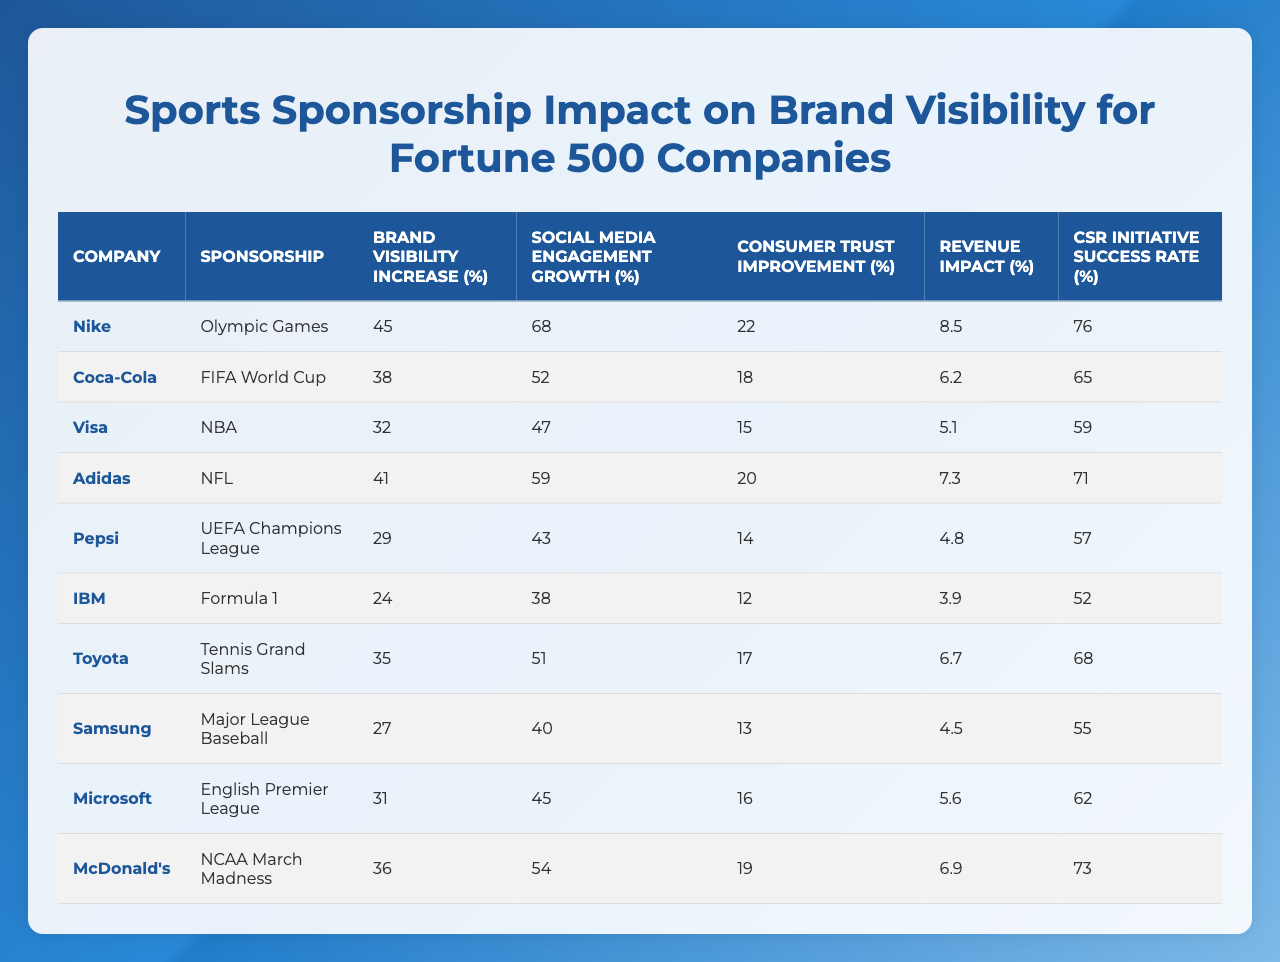What company has the highest brand visibility increase? By scanning the "Brand Visibility Increase" column, I identify Nike with a value of 45, which is the highest compared to other companies listed.
Answer: Nike Which sponsorship is associated with the lowest revenue impact percentage? By observing the "Revenue Impact Percentage" column, Pepsi has the lowest value of 4.8, making it the sponsorship with the least revenue impact.
Answer: Pepsi What is the average consumer trust improvement across all companies? The values are 22, 18, 15, 20, 14, 12, 17, 13, 16, and 19. The sum of these values is 18.6, and dividing by 10 yields an average of 18.6.
Answer: 18.6 Which company shows the most significant growth in social media engagement? Looking at the "Social Media Engagement Growth" column, Nike has the largest value of 68, indicating the most substantial growth in this area.
Answer: Nike Is the CSR initiative success rate for Coca-Cola greater than 70%? The CSR initiative success rate for Coca-Cola is 65%, which is below 70%. Thus, the answer is no.
Answer: No Which sponsorship leads to the highest consumer trust improvement and what is that value? Assessing the "Consumer Trust Improvement" column, the highest value is 22 for Nike, indicating that the Olympic Games sponsorship leads to the most significant consumer trust improvement.
Answer: 22 Calculate the total brand visibility increase for all companies combined. By summing the brand visibility increase values (45 + 38 + 32 + 41 + 29 + 24 + 35 + 27 + 31 + 36) equals 367. Therefore, the total brand visibility increase is 367.
Answer: 367 Which company has a higher social media engagement growth, Adidas or Toyota? Comparing the values from the "Social Media Engagement Growth" column shows that Adidas has 59 and Toyota has 38. Thus, Adidas has higher growth.
Answer: Adidas What percentage increase in social media engagement did Visa achieve? Visa's value in the social media engagement growth column is 52%, indicating the percentage increase achieved.
Answer: 52 Is it true that McDonald's has a higher brand visibility increase than its social media engagement growth? McDonald's brand visibility increase is 36%, and social media engagement growth is 54%. Since 36% is less than 54%, the statement is false.
Answer: No 